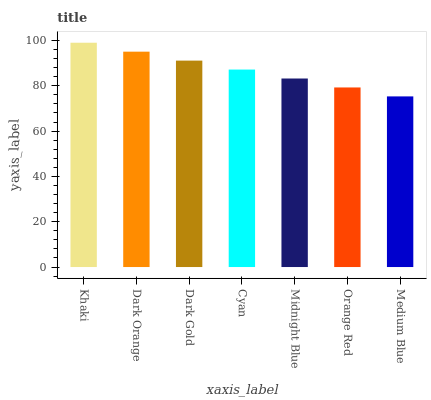Is Medium Blue the minimum?
Answer yes or no. Yes. Is Khaki the maximum?
Answer yes or no. Yes. Is Dark Orange the minimum?
Answer yes or no. No. Is Dark Orange the maximum?
Answer yes or no. No. Is Khaki greater than Dark Orange?
Answer yes or no. Yes. Is Dark Orange less than Khaki?
Answer yes or no. Yes. Is Dark Orange greater than Khaki?
Answer yes or no. No. Is Khaki less than Dark Orange?
Answer yes or no. No. Is Cyan the high median?
Answer yes or no. Yes. Is Cyan the low median?
Answer yes or no. Yes. Is Khaki the high median?
Answer yes or no. No. Is Medium Blue the low median?
Answer yes or no. No. 